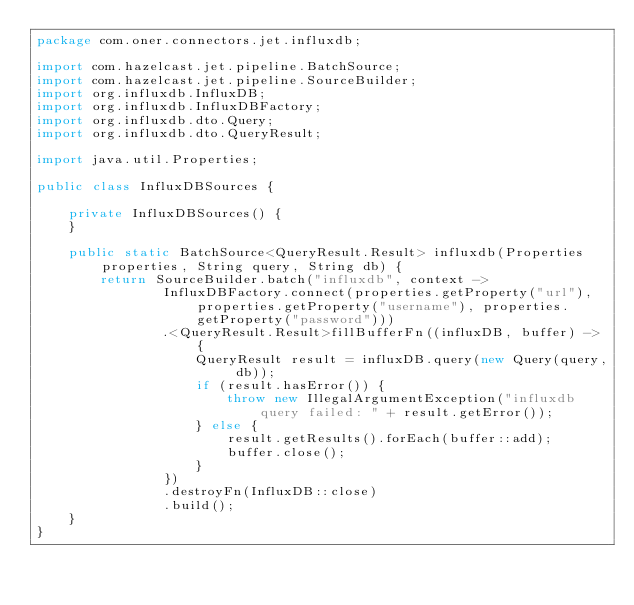<code> <loc_0><loc_0><loc_500><loc_500><_Java_>package com.oner.connectors.jet.influxdb;

import com.hazelcast.jet.pipeline.BatchSource;
import com.hazelcast.jet.pipeline.SourceBuilder;
import org.influxdb.InfluxDB;
import org.influxdb.InfluxDBFactory;
import org.influxdb.dto.Query;
import org.influxdb.dto.QueryResult;

import java.util.Properties;

public class InfluxDBSources {

    private InfluxDBSources() {
    }

    public static BatchSource<QueryResult.Result> influxdb(Properties properties, String query, String db) {
        return SourceBuilder.batch("influxdb", context ->
                InfluxDBFactory.connect(properties.getProperty("url"), properties.getProperty("username"), properties.getProperty("password")))
                .<QueryResult.Result>fillBufferFn((influxDB, buffer) -> {
                    QueryResult result = influxDB.query(new Query(query, db));
                    if (result.hasError()) {
                        throw new IllegalArgumentException("influxdb query failed: " + result.getError());
                    } else {
                        result.getResults().forEach(buffer::add);
                        buffer.close();
                    }
                })
                .destroyFn(InfluxDB::close)
                .build();
    }
}
</code> 